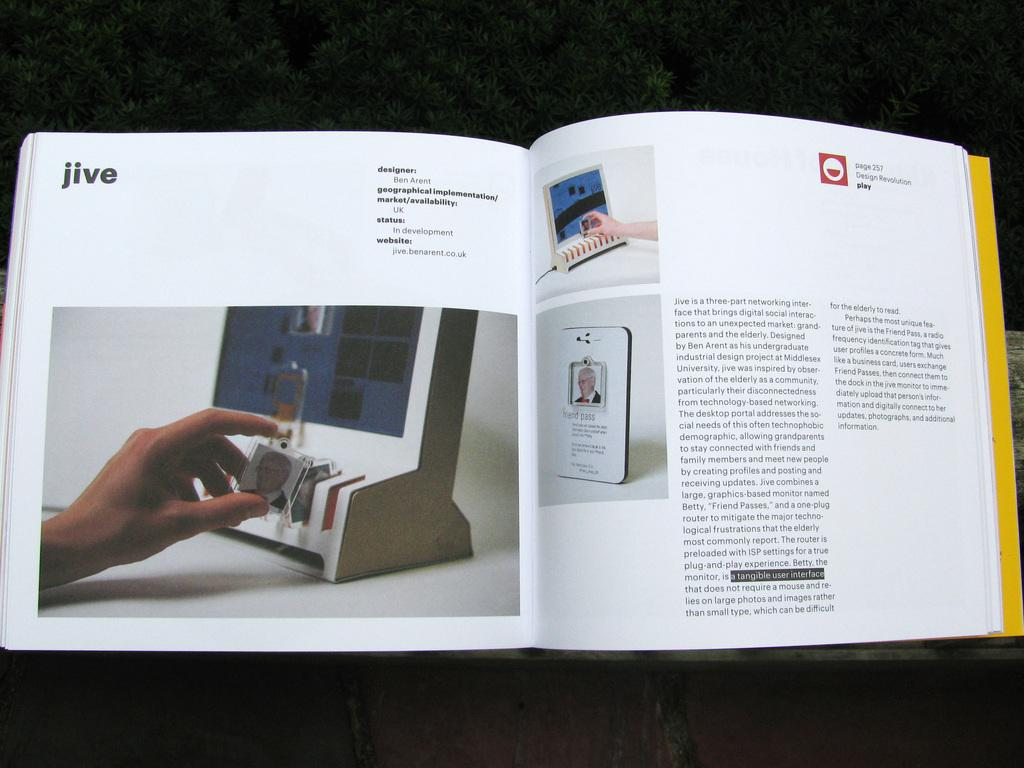<image>
Summarize the visual content of the image. A book opened to a page titled Jive shows a hand with a small photo in it. 